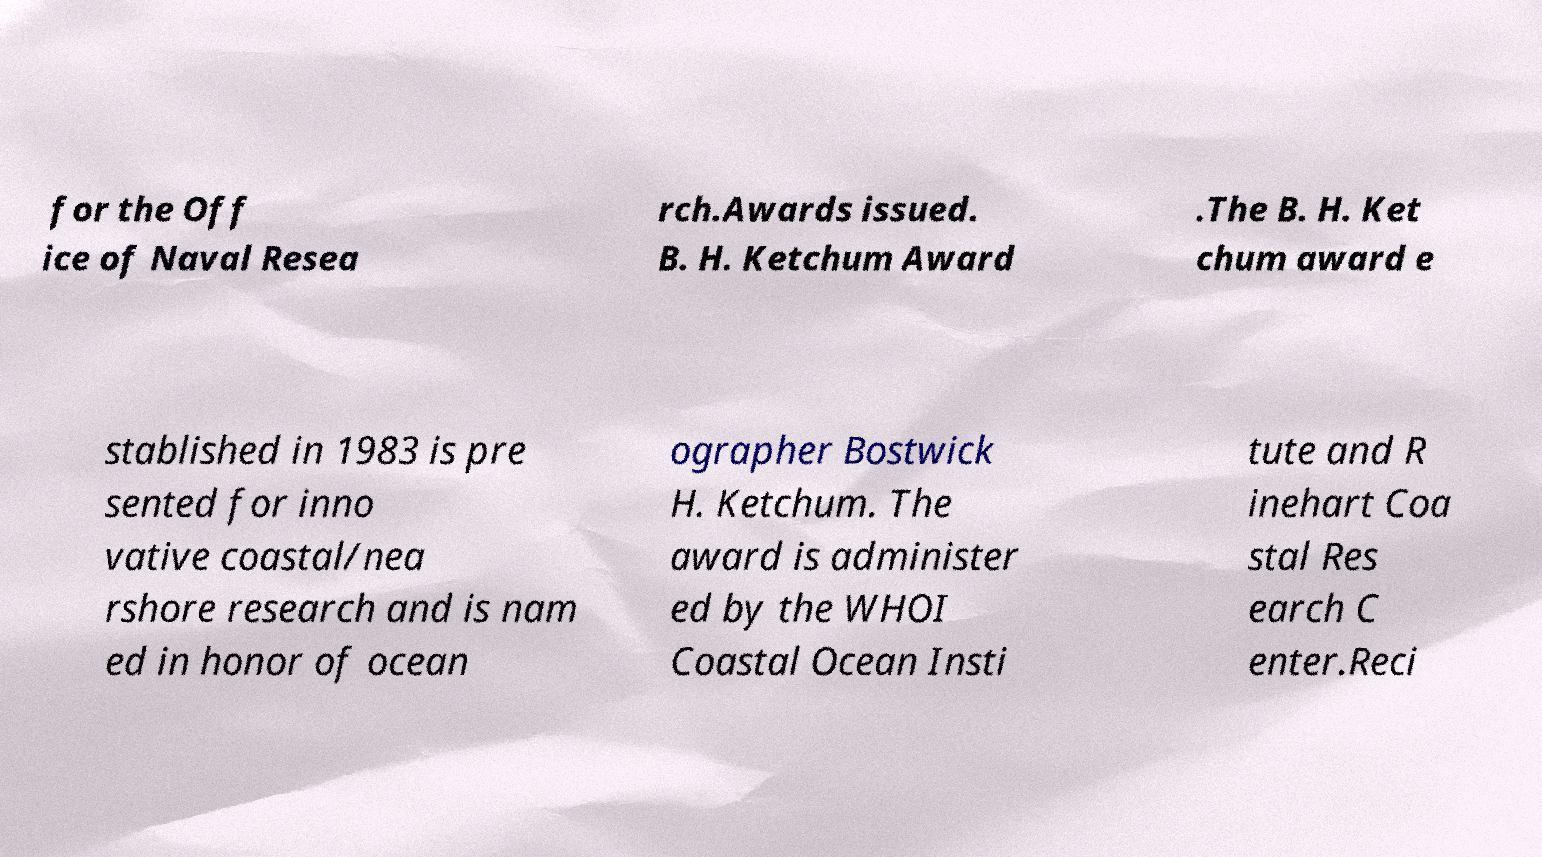Could you assist in decoding the text presented in this image and type it out clearly? for the Off ice of Naval Resea rch.Awards issued. B. H. Ketchum Award .The B. H. Ket chum award e stablished in 1983 is pre sented for inno vative coastal/nea rshore research and is nam ed in honor of ocean ographer Bostwick H. Ketchum. The award is administer ed by the WHOI Coastal Ocean Insti tute and R inehart Coa stal Res earch C enter.Reci 